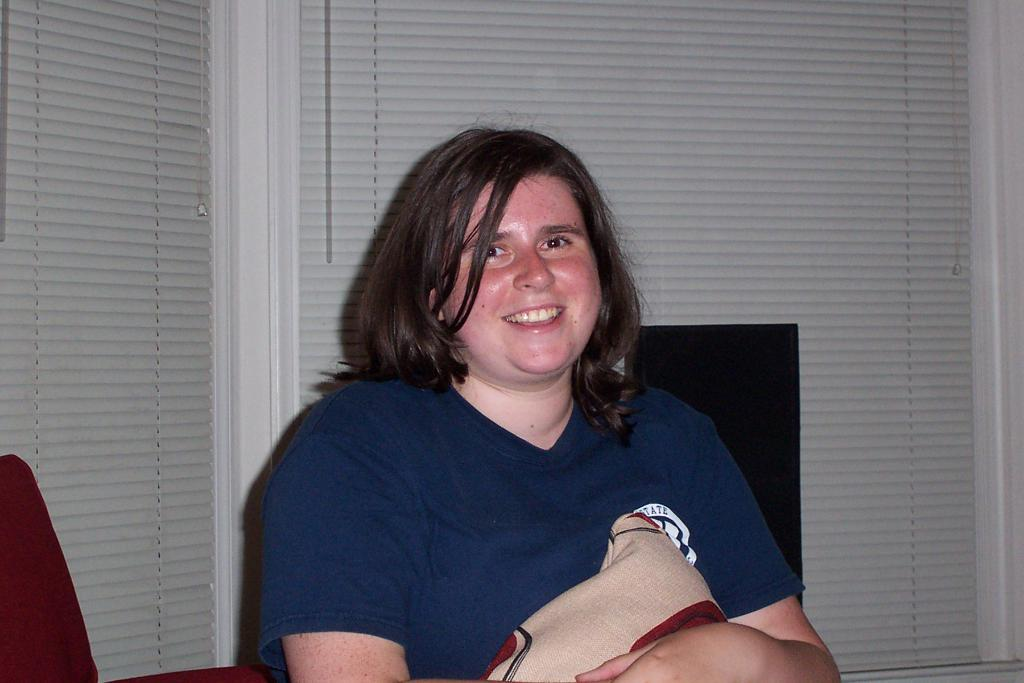Who is present in the image? There is a woman in the image. What is the woman doing in the image? The woman is sitting. What is the woman's facial expression in the image? The woman is smiling. What can be seen in the background of the image? There are white color windows in the background of the image. Where is the faucet located in the image? There is no faucet present in the image. What season is depicted in the image? The provided facts do not mention any seasonal details, so it cannot be determined from the image. 